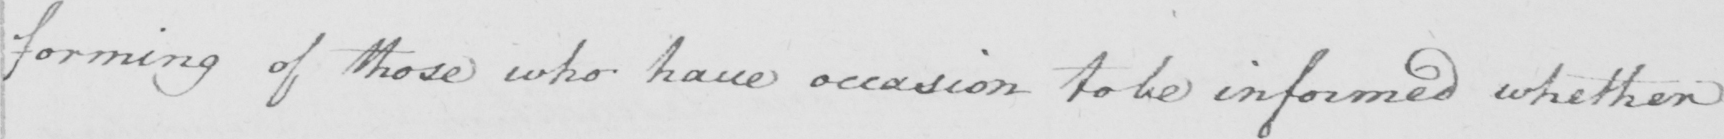What does this handwritten line say? forming of those who have occasion to be informed whether 